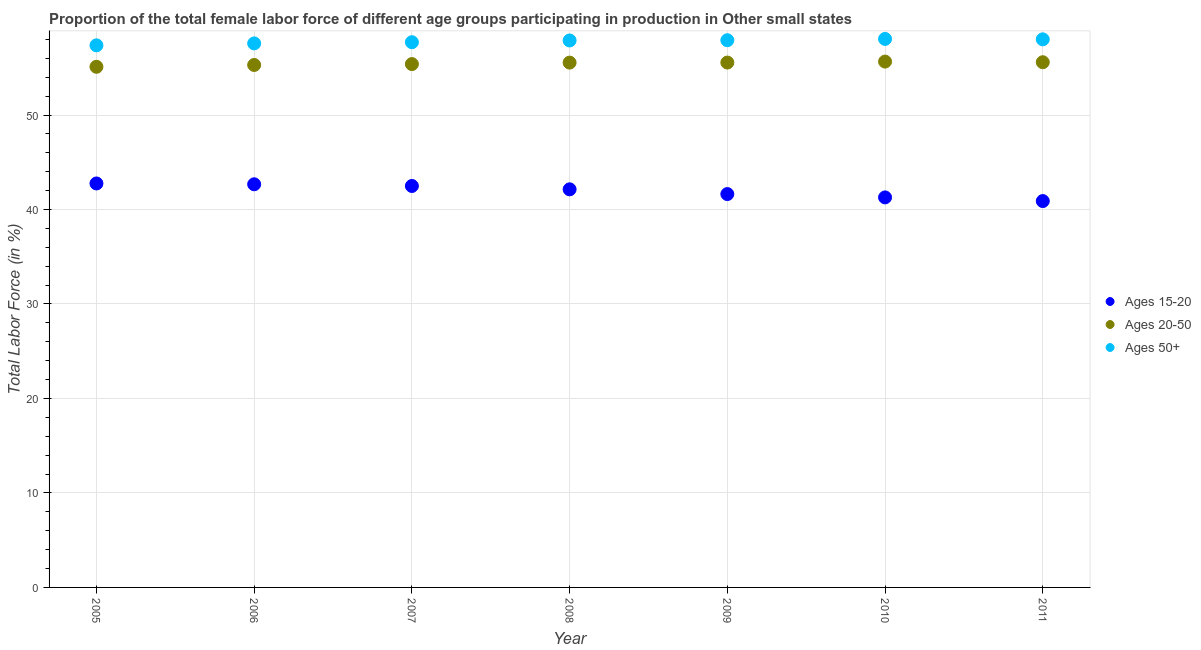How many different coloured dotlines are there?
Offer a very short reply. 3. Is the number of dotlines equal to the number of legend labels?
Make the answer very short. Yes. What is the percentage of female labor force above age 50 in 2006?
Your answer should be very brief. 57.58. Across all years, what is the maximum percentage of female labor force within the age group 20-50?
Your answer should be compact. 55.65. Across all years, what is the minimum percentage of female labor force above age 50?
Make the answer very short. 57.37. What is the total percentage of female labor force within the age group 15-20 in the graph?
Make the answer very short. 293.85. What is the difference between the percentage of female labor force within the age group 15-20 in 2005 and that in 2007?
Provide a succinct answer. 0.27. What is the difference between the percentage of female labor force within the age group 20-50 in 2011 and the percentage of female labor force above age 50 in 2007?
Make the answer very short. -2.12. What is the average percentage of female labor force above age 50 per year?
Your answer should be compact. 57.79. In the year 2008, what is the difference between the percentage of female labor force above age 50 and percentage of female labor force within the age group 20-50?
Make the answer very short. 2.34. In how many years, is the percentage of female labor force within the age group 15-20 greater than 32 %?
Provide a short and direct response. 7. What is the ratio of the percentage of female labor force above age 50 in 2005 to that in 2009?
Ensure brevity in your answer.  0.99. What is the difference between the highest and the second highest percentage of female labor force within the age group 20-50?
Offer a terse response. 0.07. What is the difference between the highest and the lowest percentage of female labor force within the age group 20-50?
Your response must be concise. 0.55. Is the percentage of female labor force above age 50 strictly greater than the percentage of female labor force within the age group 15-20 over the years?
Provide a succinct answer. Yes. How many years are there in the graph?
Offer a terse response. 7. What is the difference between two consecutive major ticks on the Y-axis?
Your response must be concise. 10. Does the graph contain grids?
Offer a terse response. Yes. Where does the legend appear in the graph?
Ensure brevity in your answer.  Center right. What is the title of the graph?
Provide a succinct answer. Proportion of the total female labor force of different age groups participating in production in Other small states. What is the label or title of the X-axis?
Offer a terse response. Year. What is the label or title of the Y-axis?
Your response must be concise. Total Labor Force (in %). What is the Total Labor Force (in %) in Ages 15-20 in 2005?
Your response must be concise. 42.75. What is the Total Labor Force (in %) in Ages 20-50 in 2005?
Your response must be concise. 55.1. What is the Total Labor Force (in %) in Ages 50+ in 2005?
Your answer should be very brief. 57.37. What is the Total Labor Force (in %) in Ages 15-20 in 2006?
Ensure brevity in your answer.  42.67. What is the Total Labor Force (in %) of Ages 20-50 in 2006?
Your response must be concise. 55.3. What is the Total Labor Force (in %) of Ages 50+ in 2006?
Provide a succinct answer. 57.58. What is the Total Labor Force (in %) in Ages 15-20 in 2007?
Offer a very short reply. 42.49. What is the Total Labor Force (in %) in Ages 20-50 in 2007?
Keep it short and to the point. 55.39. What is the Total Labor Force (in %) in Ages 50+ in 2007?
Provide a short and direct response. 57.7. What is the Total Labor Force (in %) of Ages 15-20 in 2008?
Your answer should be compact. 42.13. What is the Total Labor Force (in %) in Ages 20-50 in 2008?
Keep it short and to the point. 55.54. What is the Total Labor Force (in %) in Ages 50+ in 2008?
Ensure brevity in your answer.  57.89. What is the Total Labor Force (in %) of Ages 15-20 in 2009?
Provide a succinct answer. 41.63. What is the Total Labor Force (in %) of Ages 20-50 in 2009?
Your response must be concise. 55.55. What is the Total Labor Force (in %) in Ages 50+ in 2009?
Your answer should be very brief. 57.92. What is the Total Labor Force (in %) of Ages 15-20 in 2010?
Ensure brevity in your answer.  41.28. What is the Total Labor Force (in %) of Ages 20-50 in 2010?
Your answer should be very brief. 55.65. What is the Total Labor Force (in %) in Ages 50+ in 2010?
Ensure brevity in your answer.  58.05. What is the Total Labor Force (in %) in Ages 15-20 in 2011?
Ensure brevity in your answer.  40.89. What is the Total Labor Force (in %) of Ages 20-50 in 2011?
Make the answer very short. 55.59. What is the Total Labor Force (in %) in Ages 50+ in 2011?
Provide a succinct answer. 58.01. Across all years, what is the maximum Total Labor Force (in %) in Ages 15-20?
Your response must be concise. 42.75. Across all years, what is the maximum Total Labor Force (in %) of Ages 20-50?
Ensure brevity in your answer.  55.65. Across all years, what is the maximum Total Labor Force (in %) of Ages 50+?
Your answer should be compact. 58.05. Across all years, what is the minimum Total Labor Force (in %) of Ages 15-20?
Your response must be concise. 40.89. Across all years, what is the minimum Total Labor Force (in %) in Ages 20-50?
Your answer should be compact. 55.1. Across all years, what is the minimum Total Labor Force (in %) of Ages 50+?
Offer a very short reply. 57.37. What is the total Total Labor Force (in %) in Ages 15-20 in the graph?
Ensure brevity in your answer.  293.85. What is the total Total Labor Force (in %) in Ages 20-50 in the graph?
Offer a very short reply. 388.12. What is the total Total Labor Force (in %) in Ages 50+ in the graph?
Your answer should be compact. 404.52. What is the difference between the Total Labor Force (in %) in Ages 15-20 in 2005 and that in 2006?
Offer a very short reply. 0.09. What is the difference between the Total Labor Force (in %) in Ages 20-50 in 2005 and that in 2006?
Ensure brevity in your answer.  -0.19. What is the difference between the Total Labor Force (in %) in Ages 50+ in 2005 and that in 2006?
Your response must be concise. -0.2. What is the difference between the Total Labor Force (in %) in Ages 15-20 in 2005 and that in 2007?
Provide a succinct answer. 0.27. What is the difference between the Total Labor Force (in %) of Ages 20-50 in 2005 and that in 2007?
Provide a succinct answer. -0.29. What is the difference between the Total Labor Force (in %) in Ages 50+ in 2005 and that in 2007?
Make the answer very short. -0.33. What is the difference between the Total Labor Force (in %) in Ages 15-20 in 2005 and that in 2008?
Keep it short and to the point. 0.62. What is the difference between the Total Labor Force (in %) in Ages 20-50 in 2005 and that in 2008?
Your answer should be very brief. -0.44. What is the difference between the Total Labor Force (in %) of Ages 50+ in 2005 and that in 2008?
Make the answer very short. -0.52. What is the difference between the Total Labor Force (in %) in Ages 15-20 in 2005 and that in 2009?
Your response must be concise. 1.12. What is the difference between the Total Labor Force (in %) of Ages 20-50 in 2005 and that in 2009?
Your answer should be compact. -0.45. What is the difference between the Total Labor Force (in %) of Ages 50+ in 2005 and that in 2009?
Offer a very short reply. -0.54. What is the difference between the Total Labor Force (in %) in Ages 15-20 in 2005 and that in 2010?
Give a very brief answer. 1.48. What is the difference between the Total Labor Force (in %) of Ages 20-50 in 2005 and that in 2010?
Provide a succinct answer. -0.55. What is the difference between the Total Labor Force (in %) of Ages 50+ in 2005 and that in 2010?
Your response must be concise. -0.68. What is the difference between the Total Labor Force (in %) of Ages 15-20 in 2005 and that in 2011?
Ensure brevity in your answer.  1.86. What is the difference between the Total Labor Force (in %) of Ages 20-50 in 2005 and that in 2011?
Keep it short and to the point. -0.48. What is the difference between the Total Labor Force (in %) in Ages 50+ in 2005 and that in 2011?
Make the answer very short. -0.63. What is the difference between the Total Labor Force (in %) in Ages 15-20 in 2006 and that in 2007?
Your answer should be very brief. 0.18. What is the difference between the Total Labor Force (in %) in Ages 20-50 in 2006 and that in 2007?
Provide a succinct answer. -0.09. What is the difference between the Total Labor Force (in %) of Ages 50+ in 2006 and that in 2007?
Keep it short and to the point. -0.13. What is the difference between the Total Labor Force (in %) in Ages 15-20 in 2006 and that in 2008?
Offer a terse response. 0.53. What is the difference between the Total Labor Force (in %) of Ages 20-50 in 2006 and that in 2008?
Make the answer very short. -0.25. What is the difference between the Total Labor Force (in %) in Ages 50+ in 2006 and that in 2008?
Offer a terse response. -0.31. What is the difference between the Total Labor Force (in %) of Ages 15-20 in 2006 and that in 2009?
Offer a very short reply. 1.03. What is the difference between the Total Labor Force (in %) in Ages 20-50 in 2006 and that in 2009?
Your answer should be compact. -0.26. What is the difference between the Total Labor Force (in %) of Ages 50+ in 2006 and that in 2009?
Make the answer very short. -0.34. What is the difference between the Total Labor Force (in %) of Ages 15-20 in 2006 and that in 2010?
Keep it short and to the point. 1.39. What is the difference between the Total Labor Force (in %) in Ages 20-50 in 2006 and that in 2010?
Keep it short and to the point. -0.36. What is the difference between the Total Labor Force (in %) in Ages 50+ in 2006 and that in 2010?
Offer a terse response. -0.47. What is the difference between the Total Labor Force (in %) in Ages 15-20 in 2006 and that in 2011?
Ensure brevity in your answer.  1.78. What is the difference between the Total Labor Force (in %) of Ages 20-50 in 2006 and that in 2011?
Provide a short and direct response. -0.29. What is the difference between the Total Labor Force (in %) of Ages 50+ in 2006 and that in 2011?
Provide a short and direct response. -0.43. What is the difference between the Total Labor Force (in %) of Ages 15-20 in 2007 and that in 2008?
Offer a terse response. 0.35. What is the difference between the Total Labor Force (in %) in Ages 20-50 in 2007 and that in 2008?
Keep it short and to the point. -0.15. What is the difference between the Total Labor Force (in %) in Ages 50+ in 2007 and that in 2008?
Provide a short and direct response. -0.18. What is the difference between the Total Labor Force (in %) of Ages 15-20 in 2007 and that in 2009?
Offer a terse response. 0.86. What is the difference between the Total Labor Force (in %) of Ages 20-50 in 2007 and that in 2009?
Give a very brief answer. -0.16. What is the difference between the Total Labor Force (in %) of Ages 50+ in 2007 and that in 2009?
Your answer should be compact. -0.21. What is the difference between the Total Labor Force (in %) of Ages 15-20 in 2007 and that in 2010?
Your response must be concise. 1.21. What is the difference between the Total Labor Force (in %) of Ages 20-50 in 2007 and that in 2010?
Keep it short and to the point. -0.26. What is the difference between the Total Labor Force (in %) of Ages 50+ in 2007 and that in 2010?
Make the answer very short. -0.35. What is the difference between the Total Labor Force (in %) in Ages 15-20 in 2007 and that in 2011?
Your answer should be compact. 1.6. What is the difference between the Total Labor Force (in %) of Ages 20-50 in 2007 and that in 2011?
Your answer should be compact. -0.2. What is the difference between the Total Labor Force (in %) of Ages 50+ in 2007 and that in 2011?
Make the answer very short. -0.3. What is the difference between the Total Labor Force (in %) in Ages 15-20 in 2008 and that in 2009?
Your answer should be compact. 0.5. What is the difference between the Total Labor Force (in %) in Ages 20-50 in 2008 and that in 2009?
Offer a very short reply. -0.01. What is the difference between the Total Labor Force (in %) of Ages 50+ in 2008 and that in 2009?
Provide a short and direct response. -0.03. What is the difference between the Total Labor Force (in %) in Ages 15-20 in 2008 and that in 2010?
Your response must be concise. 0.85. What is the difference between the Total Labor Force (in %) in Ages 20-50 in 2008 and that in 2010?
Your answer should be compact. -0.11. What is the difference between the Total Labor Force (in %) in Ages 50+ in 2008 and that in 2010?
Keep it short and to the point. -0.16. What is the difference between the Total Labor Force (in %) of Ages 15-20 in 2008 and that in 2011?
Ensure brevity in your answer.  1.24. What is the difference between the Total Labor Force (in %) of Ages 20-50 in 2008 and that in 2011?
Your answer should be very brief. -0.04. What is the difference between the Total Labor Force (in %) in Ages 50+ in 2008 and that in 2011?
Give a very brief answer. -0.12. What is the difference between the Total Labor Force (in %) in Ages 15-20 in 2009 and that in 2010?
Offer a very short reply. 0.35. What is the difference between the Total Labor Force (in %) in Ages 20-50 in 2009 and that in 2010?
Your response must be concise. -0.1. What is the difference between the Total Labor Force (in %) of Ages 50+ in 2009 and that in 2010?
Your answer should be very brief. -0.14. What is the difference between the Total Labor Force (in %) of Ages 15-20 in 2009 and that in 2011?
Your response must be concise. 0.74. What is the difference between the Total Labor Force (in %) of Ages 20-50 in 2009 and that in 2011?
Provide a short and direct response. -0.03. What is the difference between the Total Labor Force (in %) of Ages 50+ in 2009 and that in 2011?
Keep it short and to the point. -0.09. What is the difference between the Total Labor Force (in %) of Ages 15-20 in 2010 and that in 2011?
Offer a very short reply. 0.39. What is the difference between the Total Labor Force (in %) in Ages 20-50 in 2010 and that in 2011?
Your answer should be compact. 0.07. What is the difference between the Total Labor Force (in %) in Ages 50+ in 2010 and that in 2011?
Offer a terse response. 0.04. What is the difference between the Total Labor Force (in %) of Ages 15-20 in 2005 and the Total Labor Force (in %) of Ages 20-50 in 2006?
Offer a very short reply. -12.54. What is the difference between the Total Labor Force (in %) in Ages 15-20 in 2005 and the Total Labor Force (in %) in Ages 50+ in 2006?
Ensure brevity in your answer.  -14.82. What is the difference between the Total Labor Force (in %) in Ages 20-50 in 2005 and the Total Labor Force (in %) in Ages 50+ in 2006?
Offer a terse response. -2.48. What is the difference between the Total Labor Force (in %) of Ages 15-20 in 2005 and the Total Labor Force (in %) of Ages 20-50 in 2007?
Give a very brief answer. -12.64. What is the difference between the Total Labor Force (in %) in Ages 15-20 in 2005 and the Total Labor Force (in %) in Ages 50+ in 2007?
Provide a succinct answer. -14.95. What is the difference between the Total Labor Force (in %) of Ages 20-50 in 2005 and the Total Labor Force (in %) of Ages 50+ in 2007?
Offer a very short reply. -2.6. What is the difference between the Total Labor Force (in %) of Ages 15-20 in 2005 and the Total Labor Force (in %) of Ages 20-50 in 2008?
Your answer should be very brief. -12.79. What is the difference between the Total Labor Force (in %) in Ages 15-20 in 2005 and the Total Labor Force (in %) in Ages 50+ in 2008?
Ensure brevity in your answer.  -15.13. What is the difference between the Total Labor Force (in %) in Ages 20-50 in 2005 and the Total Labor Force (in %) in Ages 50+ in 2008?
Keep it short and to the point. -2.79. What is the difference between the Total Labor Force (in %) in Ages 15-20 in 2005 and the Total Labor Force (in %) in Ages 20-50 in 2009?
Ensure brevity in your answer.  -12.8. What is the difference between the Total Labor Force (in %) in Ages 15-20 in 2005 and the Total Labor Force (in %) in Ages 50+ in 2009?
Your answer should be very brief. -15.16. What is the difference between the Total Labor Force (in %) in Ages 20-50 in 2005 and the Total Labor Force (in %) in Ages 50+ in 2009?
Ensure brevity in your answer.  -2.81. What is the difference between the Total Labor Force (in %) of Ages 15-20 in 2005 and the Total Labor Force (in %) of Ages 20-50 in 2010?
Make the answer very short. -12.9. What is the difference between the Total Labor Force (in %) of Ages 15-20 in 2005 and the Total Labor Force (in %) of Ages 50+ in 2010?
Your answer should be very brief. -15.3. What is the difference between the Total Labor Force (in %) of Ages 20-50 in 2005 and the Total Labor Force (in %) of Ages 50+ in 2010?
Give a very brief answer. -2.95. What is the difference between the Total Labor Force (in %) in Ages 15-20 in 2005 and the Total Labor Force (in %) in Ages 20-50 in 2011?
Offer a very short reply. -12.83. What is the difference between the Total Labor Force (in %) of Ages 15-20 in 2005 and the Total Labor Force (in %) of Ages 50+ in 2011?
Provide a succinct answer. -15.25. What is the difference between the Total Labor Force (in %) in Ages 20-50 in 2005 and the Total Labor Force (in %) in Ages 50+ in 2011?
Offer a very short reply. -2.91. What is the difference between the Total Labor Force (in %) of Ages 15-20 in 2006 and the Total Labor Force (in %) of Ages 20-50 in 2007?
Your answer should be compact. -12.72. What is the difference between the Total Labor Force (in %) in Ages 15-20 in 2006 and the Total Labor Force (in %) in Ages 50+ in 2007?
Your response must be concise. -15.04. What is the difference between the Total Labor Force (in %) of Ages 20-50 in 2006 and the Total Labor Force (in %) of Ages 50+ in 2007?
Provide a short and direct response. -2.41. What is the difference between the Total Labor Force (in %) of Ages 15-20 in 2006 and the Total Labor Force (in %) of Ages 20-50 in 2008?
Your answer should be compact. -12.88. What is the difference between the Total Labor Force (in %) of Ages 15-20 in 2006 and the Total Labor Force (in %) of Ages 50+ in 2008?
Provide a short and direct response. -15.22. What is the difference between the Total Labor Force (in %) in Ages 20-50 in 2006 and the Total Labor Force (in %) in Ages 50+ in 2008?
Provide a short and direct response. -2.59. What is the difference between the Total Labor Force (in %) in Ages 15-20 in 2006 and the Total Labor Force (in %) in Ages 20-50 in 2009?
Your answer should be very brief. -12.88. What is the difference between the Total Labor Force (in %) of Ages 15-20 in 2006 and the Total Labor Force (in %) of Ages 50+ in 2009?
Make the answer very short. -15.25. What is the difference between the Total Labor Force (in %) of Ages 20-50 in 2006 and the Total Labor Force (in %) of Ages 50+ in 2009?
Offer a very short reply. -2.62. What is the difference between the Total Labor Force (in %) in Ages 15-20 in 2006 and the Total Labor Force (in %) in Ages 20-50 in 2010?
Your answer should be compact. -12.99. What is the difference between the Total Labor Force (in %) of Ages 15-20 in 2006 and the Total Labor Force (in %) of Ages 50+ in 2010?
Provide a succinct answer. -15.38. What is the difference between the Total Labor Force (in %) of Ages 20-50 in 2006 and the Total Labor Force (in %) of Ages 50+ in 2010?
Provide a short and direct response. -2.76. What is the difference between the Total Labor Force (in %) of Ages 15-20 in 2006 and the Total Labor Force (in %) of Ages 20-50 in 2011?
Make the answer very short. -12.92. What is the difference between the Total Labor Force (in %) of Ages 15-20 in 2006 and the Total Labor Force (in %) of Ages 50+ in 2011?
Make the answer very short. -15.34. What is the difference between the Total Labor Force (in %) in Ages 20-50 in 2006 and the Total Labor Force (in %) in Ages 50+ in 2011?
Your answer should be compact. -2.71. What is the difference between the Total Labor Force (in %) in Ages 15-20 in 2007 and the Total Labor Force (in %) in Ages 20-50 in 2008?
Keep it short and to the point. -13.06. What is the difference between the Total Labor Force (in %) of Ages 15-20 in 2007 and the Total Labor Force (in %) of Ages 50+ in 2008?
Your answer should be compact. -15.4. What is the difference between the Total Labor Force (in %) in Ages 20-50 in 2007 and the Total Labor Force (in %) in Ages 50+ in 2008?
Your answer should be compact. -2.5. What is the difference between the Total Labor Force (in %) in Ages 15-20 in 2007 and the Total Labor Force (in %) in Ages 20-50 in 2009?
Make the answer very short. -13.06. What is the difference between the Total Labor Force (in %) of Ages 15-20 in 2007 and the Total Labor Force (in %) of Ages 50+ in 2009?
Provide a short and direct response. -15.43. What is the difference between the Total Labor Force (in %) of Ages 20-50 in 2007 and the Total Labor Force (in %) of Ages 50+ in 2009?
Ensure brevity in your answer.  -2.53. What is the difference between the Total Labor Force (in %) of Ages 15-20 in 2007 and the Total Labor Force (in %) of Ages 20-50 in 2010?
Your answer should be very brief. -13.17. What is the difference between the Total Labor Force (in %) in Ages 15-20 in 2007 and the Total Labor Force (in %) in Ages 50+ in 2010?
Your answer should be very brief. -15.56. What is the difference between the Total Labor Force (in %) in Ages 20-50 in 2007 and the Total Labor Force (in %) in Ages 50+ in 2010?
Give a very brief answer. -2.66. What is the difference between the Total Labor Force (in %) in Ages 15-20 in 2007 and the Total Labor Force (in %) in Ages 20-50 in 2011?
Ensure brevity in your answer.  -13.1. What is the difference between the Total Labor Force (in %) of Ages 15-20 in 2007 and the Total Labor Force (in %) of Ages 50+ in 2011?
Your response must be concise. -15.52. What is the difference between the Total Labor Force (in %) in Ages 20-50 in 2007 and the Total Labor Force (in %) in Ages 50+ in 2011?
Ensure brevity in your answer.  -2.62. What is the difference between the Total Labor Force (in %) in Ages 15-20 in 2008 and the Total Labor Force (in %) in Ages 20-50 in 2009?
Your answer should be compact. -13.42. What is the difference between the Total Labor Force (in %) of Ages 15-20 in 2008 and the Total Labor Force (in %) of Ages 50+ in 2009?
Keep it short and to the point. -15.78. What is the difference between the Total Labor Force (in %) in Ages 20-50 in 2008 and the Total Labor Force (in %) in Ages 50+ in 2009?
Offer a very short reply. -2.37. What is the difference between the Total Labor Force (in %) in Ages 15-20 in 2008 and the Total Labor Force (in %) in Ages 20-50 in 2010?
Keep it short and to the point. -13.52. What is the difference between the Total Labor Force (in %) of Ages 15-20 in 2008 and the Total Labor Force (in %) of Ages 50+ in 2010?
Provide a short and direct response. -15.92. What is the difference between the Total Labor Force (in %) in Ages 20-50 in 2008 and the Total Labor Force (in %) in Ages 50+ in 2010?
Provide a succinct answer. -2.51. What is the difference between the Total Labor Force (in %) of Ages 15-20 in 2008 and the Total Labor Force (in %) of Ages 20-50 in 2011?
Provide a short and direct response. -13.45. What is the difference between the Total Labor Force (in %) in Ages 15-20 in 2008 and the Total Labor Force (in %) in Ages 50+ in 2011?
Keep it short and to the point. -15.87. What is the difference between the Total Labor Force (in %) of Ages 20-50 in 2008 and the Total Labor Force (in %) of Ages 50+ in 2011?
Give a very brief answer. -2.46. What is the difference between the Total Labor Force (in %) of Ages 15-20 in 2009 and the Total Labor Force (in %) of Ages 20-50 in 2010?
Give a very brief answer. -14.02. What is the difference between the Total Labor Force (in %) of Ages 15-20 in 2009 and the Total Labor Force (in %) of Ages 50+ in 2010?
Make the answer very short. -16.42. What is the difference between the Total Labor Force (in %) in Ages 20-50 in 2009 and the Total Labor Force (in %) in Ages 50+ in 2010?
Offer a very short reply. -2.5. What is the difference between the Total Labor Force (in %) in Ages 15-20 in 2009 and the Total Labor Force (in %) in Ages 20-50 in 2011?
Keep it short and to the point. -13.95. What is the difference between the Total Labor Force (in %) in Ages 15-20 in 2009 and the Total Labor Force (in %) in Ages 50+ in 2011?
Keep it short and to the point. -16.38. What is the difference between the Total Labor Force (in %) in Ages 20-50 in 2009 and the Total Labor Force (in %) in Ages 50+ in 2011?
Offer a terse response. -2.46. What is the difference between the Total Labor Force (in %) of Ages 15-20 in 2010 and the Total Labor Force (in %) of Ages 20-50 in 2011?
Provide a succinct answer. -14.31. What is the difference between the Total Labor Force (in %) of Ages 15-20 in 2010 and the Total Labor Force (in %) of Ages 50+ in 2011?
Ensure brevity in your answer.  -16.73. What is the difference between the Total Labor Force (in %) of Ages 20-50 in 2010 and the Total Labor Force (in %) of Ages 50+ in 2011?
Your answer should be very brief. -2.35. What is the average Total Labor Force (in %) of Ages 15-20 per year?
Provide a succinct answer. 41.98. What is the average Total Labor Force (in %) of Ages 20-50 per year?
Offer a terse response. 55.45. What is the average Total Labor Force (in %) in Ages 50+ per year?
Your answer should be very brief. 57.79. In the year 2005, what is the difference between the Total Labor Force (in %) in Ages 15-20 and Total Labor Force (in %) in Ages 20-50?
Offer a very short reply. -12.35. In the year 2005, what is the difference between the Total Labor Force (in %) in Ages 15-20 and Total Labor Force (in %) in Ages 50+?
Offer a terse response. -14.62. In the year 2005, what is the difference between the Total Labor Force (in %) of Ages 20-50 and Total Labor Force (in %) of Ages 50+?
Your answer should be compact. -2.27. In the year 2006, what is the difference between the Total Labor Force (in %) of Ages 15-20 and Total Labor Force (in %) of Ages 20-50?
Give a very brief answer. -12.63. In the year 2006, what is the difference between the Total Labor Force (in %) in Ages 15-20 and Total Labor Force (in %) in Ages 50+?
Provide a short and direct response. -14.91. In the year 2006, what is the difference between the Total Labor Force (in %) in Ages 20-50 and Total Labor Force (in %) in Ages 50+?
Give a very brief answer. -2.28. In the year 2007, what is the difference between the Total Labor Force (in %) in Ages 15-20 and Total Labor Force (in %) in Ages 20-50?
Give a very brief answer. -12.9. In the year 2007, what is the difference between the Total Labor Force (in %) of Ages 15-20 and Total Labor Force (in %) of Ages 50+?
Make the answer very short. -15.22. In the year 2007, what is the difference between the Total Labor Force (in %) in Ages 20-50 and Total Labor Force (in %) in Ages 50+?
Your answer should be compact. -2.31. In the year 2008, what is the difference between the Total Labor Force (in %) in Ages 15-20 and Total Labor Force (in %) in Ages 20-50?
Provide a short and direct response. -13.41. In the year 2008, what is the difference between the Total Labor Force (in %) of Ages 15-20 and Total Labor Force (in %) of Ages 50+?
Your answer should be very brief. -15.75. In the year 2008, what is the difference between the Total Labor Force (in %) of Ages 20-50 and Total Labor Force (in %) of Ages 50+?
Keep it short and to the point. -2.34. In the year 2009, what is the difference between the Total Labor Force (in %) of Ages 15-20 and Total Labor Force (in %) of Ages 20-50?
Make the answer very short. -13.92. In the year 2009, what is the difference between the Total Labor Force (in %) of Ages 15-20 and Total Labor Force (in %) of Ages 50+?
Your answer should be very brief. -16.28. In the year 2009, what is the difference between the Total Labor Force (in %) of Ages 20-50 and Total Labor Force (in %) of Ages 50+?
Give a very brief answer. -2.36. In the year 2010, what is the difference between the Total Labor Force (in %) in Ages 15-20 and Total Labor Force (in %) in Ages 20-50?
Offer a terse response. -14.38. In the year 2010, what is the difference between the Total Labor Force (in %) of Ages 15-20 and Total Labor Force (in %) of Ages 50+?
Provide a short and direct response. -16.77. In the year 2010, what is the difference between the Total Labor Force (in %) of Ages 20-50 and Total Labor Force (in %) of Ages 50+?
Your answer should be compact. -2.4. In the year 2011, what is the difference between the Total Labor Force (in %) in Ages 15-20 and Total Labor Force (in %) in Ages 20-50?
Make the answer very short. -14.69. In the year 2011, what is the difference between the Total Labor Force (in %) in Ages 15-20 and Total Labor Force (in %) in Ages 50+?
Keep it short and to the point. -17.12. In the year 2011, what is the difference between the Total Labor Force (in %) of Ages 20-50 and Total Labor Force (in %) of Ages 50+?
Your answer should be very brief. -2.42. What is the ratio of the Total Labor Force (in %) in Ages 50+ in 2005 to that in 2007?
Give a very brief answer. 0.99. What is the ratio of the Total Labor Force (in %) of Ages 15-20 in 2005 to that in 2008?
Ensure brevity in your answer.  1.01. What is the ratio of the Total Labor Force (in %) in Ages 20-50 in 2005 to that in 2008?
Offer a terse response. 0.99. What is the ratio of the Total Labor Force (in %) of Ages 50+ in 2005 to that in 2008?
Provide a short and direct response. 0.99. What is the ratio of the Total Labor Force (in %) of Ages 15-20 in 2005 to that in 2009?
Your response must be concise. 1.03. What is the ratio of the Total Labor Force (in %) in Ages 50+ in 2005 to that in 2009?
Provide a succinct answer. 0.99. What is the ratio of the Total Labor Force (in %) in Ages 15-20 in 2005 to that in 2010?
Your response must be concise. 1.04. What is the ratio of the Total Labor Force (in %) in Ages 20-50 in 2005 to that in 2010?
Provide a short and direct response. 0.99. What is the ratio of the Total Labor Force (in %) in Ages 50+ in 2005 to that in 2010?
Your answer should be very brief. 0.99. What is the ratio of the Total Labor Force (in %) of Ages 15-20 in 2005 to that in 2011?
Your response must be concise. 1.05. What is the ratio of the Total Labor Force (in %) in Ages 20-50 in 2006 to that in 2007?
Your answer should be very brief. 1. What is the ratio of the Total Labor Force (in %) of Ages 50+ in 2006 to that in 2007?
Your answer should be compact. 1. What is the ratio of the Total Labor Force (in %) in Ages 15-20 in 2006 to that in 2008?
Provide a succinct answer. 1.01. What is the ratio of the Total Labor Force (in %) in Ages 20-50 in 2006 to that in 2008?
Your answer should be compact. 1. What is the ratio of the Total Labor Force (in %) in Ages 15-20 in 2006 to that in 2009?
Keep it short and to the point. 1.02. What is the ratio of the Total Labor Force (in %) in Ages 20-50 in 2006 to that in 2009?
Your response must be concise. 1. What is the ratio of the Total Labor Force (in %) in Ages 15-20 in 2006 to that in 2010?
Make the answer very short. 1.03. What is the ratio of the Total Labor Force (in %) in Ages 20-50 in 2006 to that in 2010?
Offer a terse response. 0.99. What is the ratio of the Total Labor Force (in %) in Ages 15-20 in 2006 to that in 2011?
Offer a very short reply. 1.04. What is the ratio of the Total Labor Force (in %) in Ages 15-20 in 2007 to that in 2008?
Your answer should be very brief. 1.01. What is the ratio of the Total Labor Force (in %) of Ages 15-20 in 2007 to that in 2009?
Offer a terse response. 1.02. What is the ratio of the Total Labor Force (in %) in Ages 15-20 in 2007 to that in 2010?
Your answer should be very brief. 1.03. What is the ratio of the Total Labor Force (in %) of Ages 50+ in 2007 to that in 2010?
Offer a terse response. 0.99. What is the ratio of the Total Labor Force (in %) of Ages 15-20 in 2007 to that in 2011?
Ensure brevity in your answer.  1.04. What is the ratio of the Total Labor Force (in %) in Ages 20-50 in 2007 to that in 2011?
Your response must be concise. 1. What is the ratio of the Total Labor Force (in %) in Ages 20-50 in 2008 to that in 2009?
Offer a very short reply. 1. What is the ratio of the Total Labor Force (in %) of Ages 50+ in 2008 to that in 2009?
Provide a short and direct response. 1. What is the ratio of the Total Labor Force (in %) in Ages 15-20 in 2008 to that in 2010?
Provide a short and direct response. 1.02. What is the ratio of the Total Labor Force (in %) in Ages 20-50 in 2008 to that in 2010?
Your answer should be very brief. 1. What is the ratio of the Total Labor Force (in %) in Ages 50+ in 2008 to that in 2010?
Keep it short and to the point. 1. What is the ratio of the Total Labor Force (in %) of Ages 15-20 in 2008 to that in 2011?
Give a very brief answer. 1.03. What is the ratio of the Total Labor Force (in %) of Ages 20-50 in 2008 to that in 2011?
Provide a succinct answer. 1. What is the ratio of the Total Labor Force (in %) of Ages 15-20 in 2009 to that in 2010?
Offer a terse response. 1.01. What is the ratio of the Total Labor Force (in %) in Ages 20-50 in 2009 to that in 2010?
Make the answer very short. 1. What is the ratio of the Total Labor Force (in %) in Ages 15-20 in 2009 to that in 2011?
Make the answer very short. 1.02. What is the ratio of the Total Labor Force (in %) in Ages 20-50 in 2009 to that in 2011?
Keep it short and to the point. 1. What is the ratio of the Total Labor Force (in %) of Ages 15-20 in 2010 to that in 2011?
Your answer should be compact. 1.01. What is the difference between the highest and the second highest Total Labor Force (in %) in Ages 15-20?
Provide a succinct answer. 0.09. What is the difference between the highest and the second highest Total Labor Force (in %) in Ages 20-50?
Keep it short and to the point. 0.07. What is the difference between the highest and the second highest Total Labor Force (in %) in Ages 50+?
Your response must be concise. 0.04. What is the difference between the highest and the lowest Total Labor Force (in %) in Ages 15-20?
Provide a succinct answer. 1.86. What is the difference between the highest and the lowest Total Labor Force (in %) of Ages 20-50?
Ensure brevity in your answer.  0.55. What is the difference between the highest and the lowest Total Labor Force (in %) in Ages 50+?
Provide a succinct answer. 0.68. 